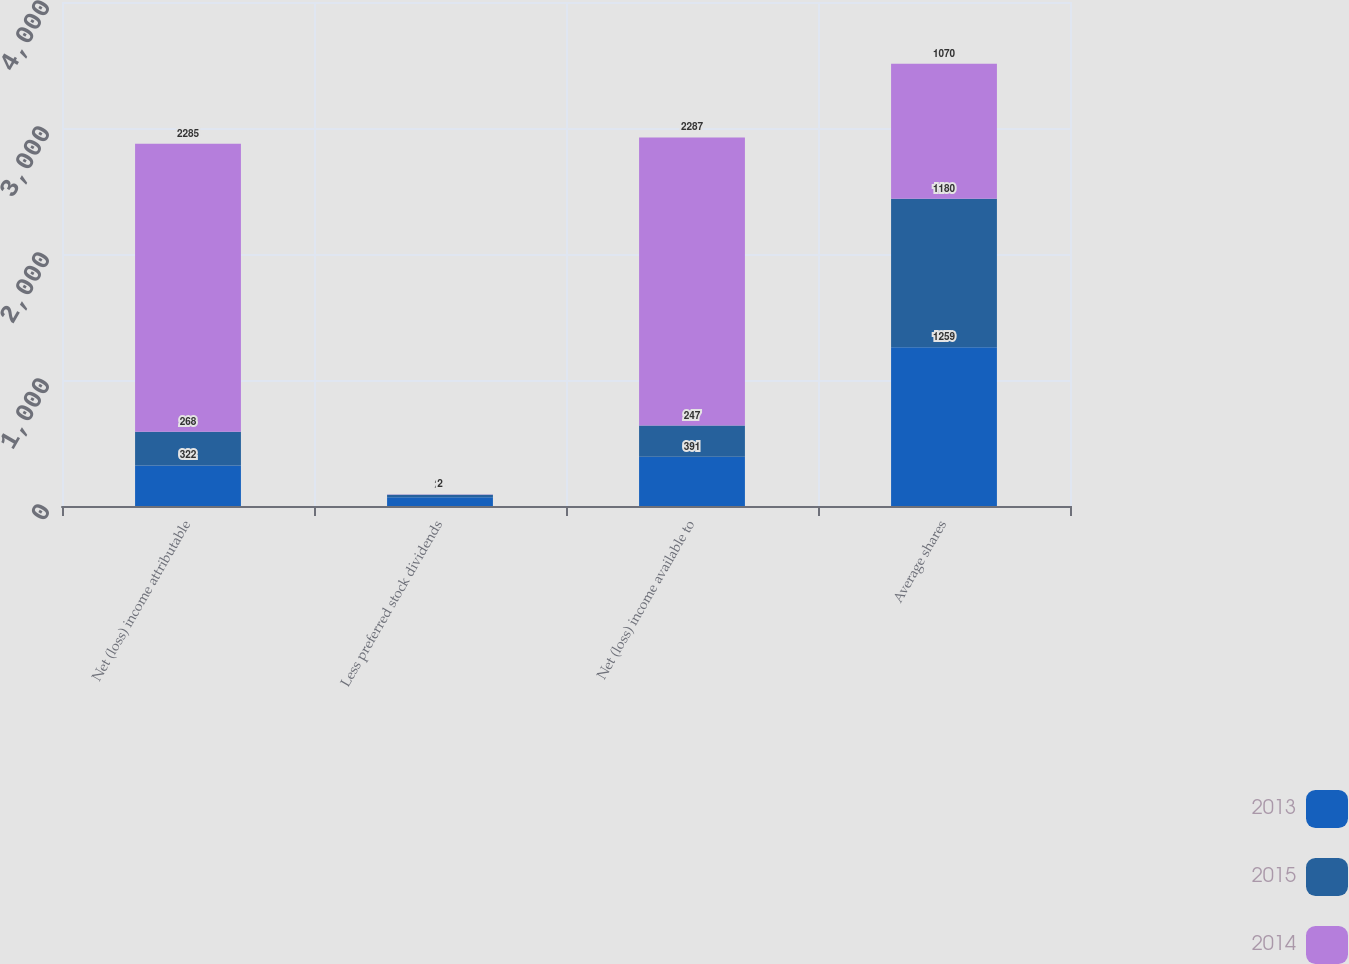Convert chart to OTSL. <chart><loc_0><loc_0><loc_500><loc_500><stacked_bar_chart><ecel><fcel>Net (loss) income attributable<fcel>Less preferred stock dividends<fcel>Net (loss) income available to<fcel>Average shares<nl><fcel>2013<fcel>322<fcel>69<fcel>391<fcel>1259<nl><fcel>2015<fcel>268<fcel>21<fcel>247<fcel>1180<nl><fcel>2014<fcel>2285<fcel>2<fcel>2287<fcel>1070<nl></chart> 